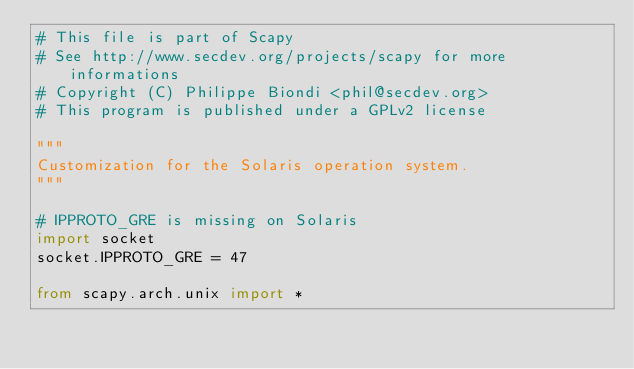<code> <loc_0><loc_0><loc_500><loc_500><_Python_># This file is part of Scapy
# See http://www.secdev.org/projects/scapy for more informations
# Copyright (C) Philippe Biondi <phil@secdev.org>
# This program is published under a GPLv2 license

"""
Customization for the Solaris operation system.
"""

# IPPROTO_GRE is missing on Solaris
import socket
socket.IPPROTO_GRE = 47

from scapy.arch.unix import *
</code> 